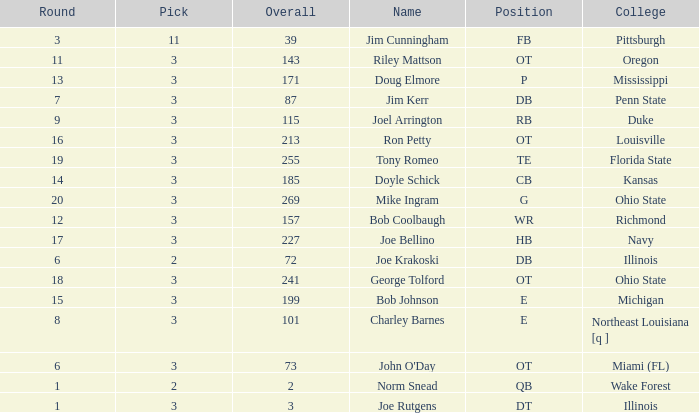How many rounds have john o'day as the name, and a pick less than 3? None. 